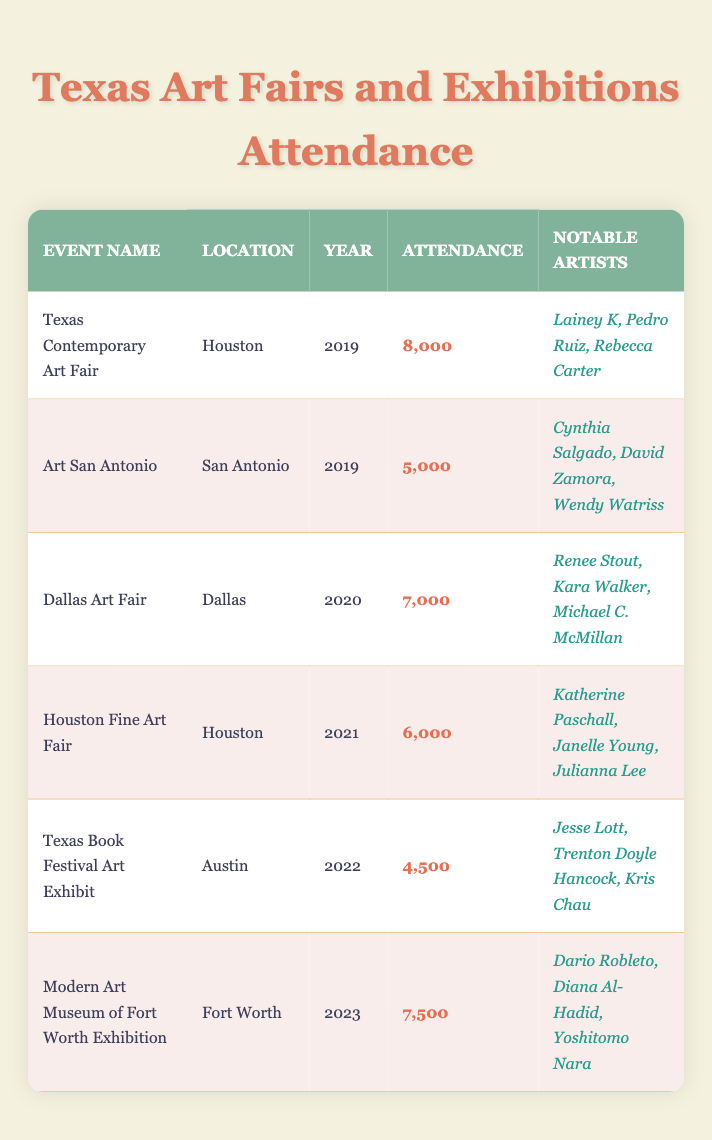What was the highest attendance at an art fair in Texas over the past five years? The table lists the attendance for each event. The Texas Contemporary Art Fair in 2019 had the highest attendance at 8,000.
Answer: 8,000 Which event in Austin had the lowest attendance? The Texas Book Festival Art Exhibit in 2022 had the lowest attendance, with 4,500 attendees.
Answer: 4,500 How many years were there art fairs with attendance over 6,000? The years with attendance over 6,000 are 2019 (Texas Contemporary Art Fair), 2020 (Dallas Art Fair), 2021 (Houston Fine Art Fair), and 2023 (Modern Art Museum of Fort Worth Exhibition). That's four years.
Answer: 4 Did the attendance at the Dallas Art Fair increase or decrease from the previous year (2019)? The Dallas Art Fair in 2020 had 7,000 attendees, which is an increase compared to 5,000 attendees at Art San Antonio in 2019.
Answer: Increase Which notable artist appeared at the Texas Contemporary Art Fair? The Texas Contemporary Art Fair in 2019 featured notable artists Lainey K, Pedro Ruiz, and Rebecca Carter.
Answer: Lainey K, Pedro Ruiz, Rebecca Carter What was the total attendance of all events held in Houston? The events held in Houston were the Texas Contemporary Art Fair (2019) with 8,000 attendees and the Houston Fine Art Fair (2021) with 6,000 attendees. The total attendance is 8,000 + 6,000 = 14,000.
Answer: 14,000 Was there a year when an art fair in Texas had exactly 5,000 attendees? Yes, the Art San Antonio in 2019 had exactly 5,000 attendees.
Answer: Yes Which event had the most notable artists listed? The Texas Contemporary Art Fair (2019) had three notable artists: Lainey K, Pedro Ruiz, and Rebecca Carter. No other events had more listed.
Answer: Texas Contemporary Art Fair 